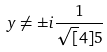Convert formula to latex. <formula><loc_0><loc_0><loc_500><loc_500>y \ne \pm i \frac { 1 } { \sqrt { [ } 4 ] { 5 } }</formula> 